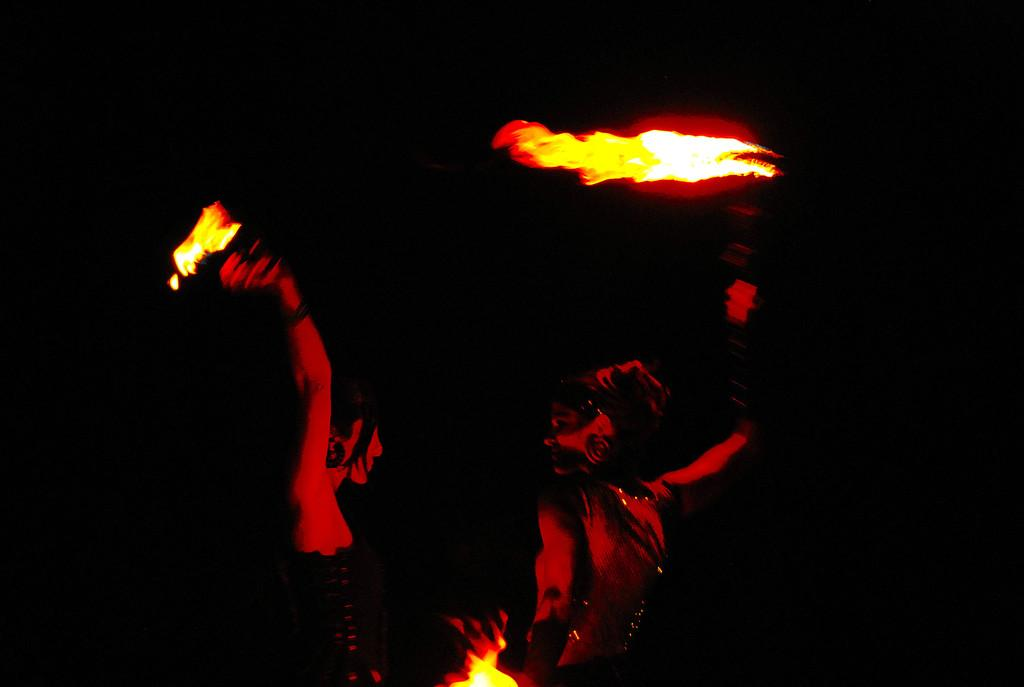How many people are in the image? There are two people in the image. What is happening in the image? There is a fire in the image. What is the color of the background in the image? The background of the image is black. What type of steel is being used to create the club in the image? There is no steel or club present in the image; it features two people and a fire. Can you see any steam coming from the fire in the image? The provided facts do not mention steam, so it cannot be determined if steam is present in the image. 